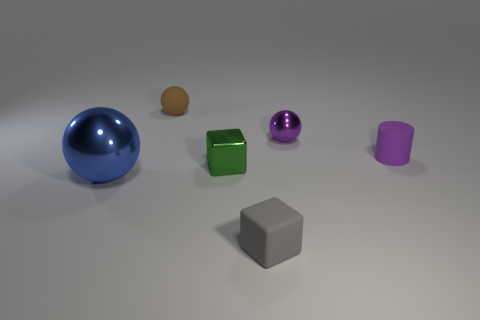Subtract 1 spheres. How many spheres are left? 2 Add 4 large gray metallic cubes. How many objects exist? 10 Subtract all cylinders. How many objects are left? 5 Add 2 purple things. How many purple things are left? 4 Add 2 big blue balls. How many big blue balls exist? 3 Subtract 0 gray balls. How many objects are left? 6 Subtract all blue matte spheres. Subtract all small rubber cubes. How many objects are left? 5 